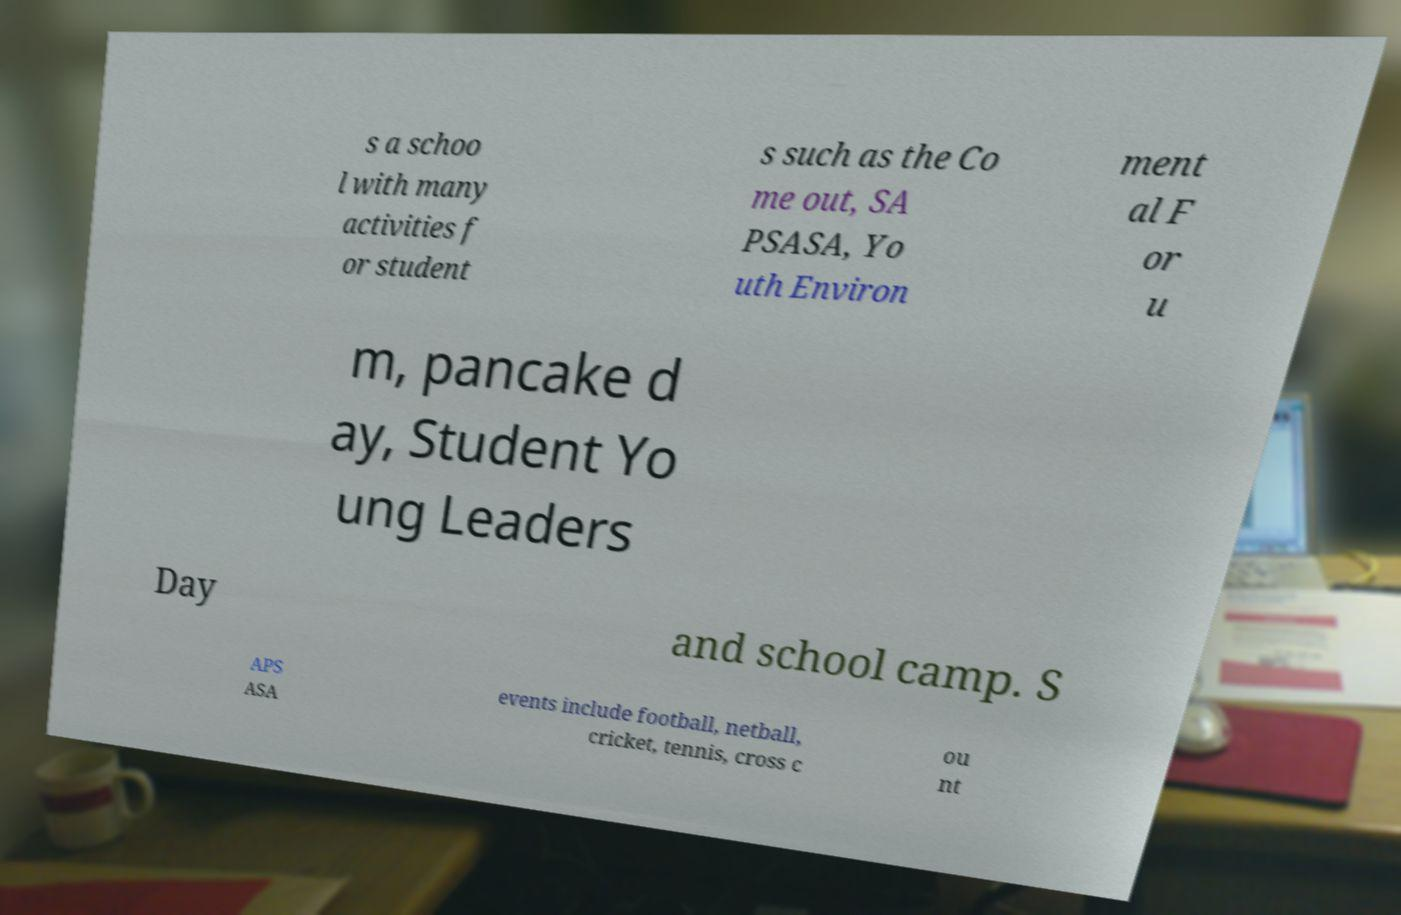What messages or text are displayed in this image? I need them in a readable, typed format. s a schoo l with many activities f or student s such as the Co me out, SA PSASA, Yo uth Environ ment al F or u m, pancake d ay, Student Yo ung Leaders Day and school camp. S APS ASA events include football, netball, cricket, tennis, cross c ou nt 